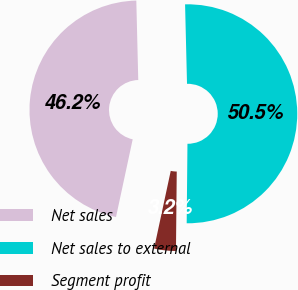Convert chart to OTSL. <chart><loc_0><loc_0><loc_500><loc_500><pie_chart><fcel>Net sales<fcel>Net sales to external<fcel>Segment profit<nl><fcel>46.24%<fcel>50.54%<fcel>3.21%<nl></chart> 